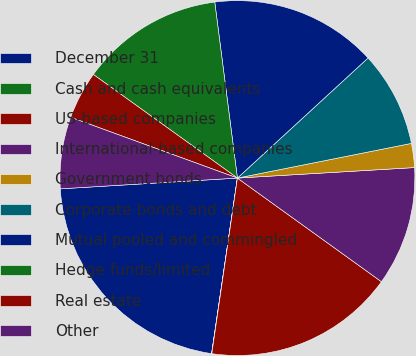<chart> <loc_0><loc_0><loc_500><loc_500><pie_chart><fcel>December 31<fcel>Cash and cash equivalents<fcel>US-based companies<fcel>International-based companies<fcel>Government bonds<fcel>Corporate bonds and debt<fcel>Mutual pooled and commingled<fcel>Hedge funds/limited<fcel>Real estate<fcel>Other<nl><fcel>21.71%<fcel>0.02%<fcel>17.38%<fcel>10.87%<fcel>2.19%<fcel>8.7%<fcel>15.21%<fcel>13.04%<fcel>4.36%<fcel>6.53%<nl></chart> 